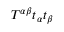<formula> <loc_0><loc_0><loc_500><loc_500>T ^ { \alpha \beta } t _ { \alpha } t _ { \beta }</formula> 